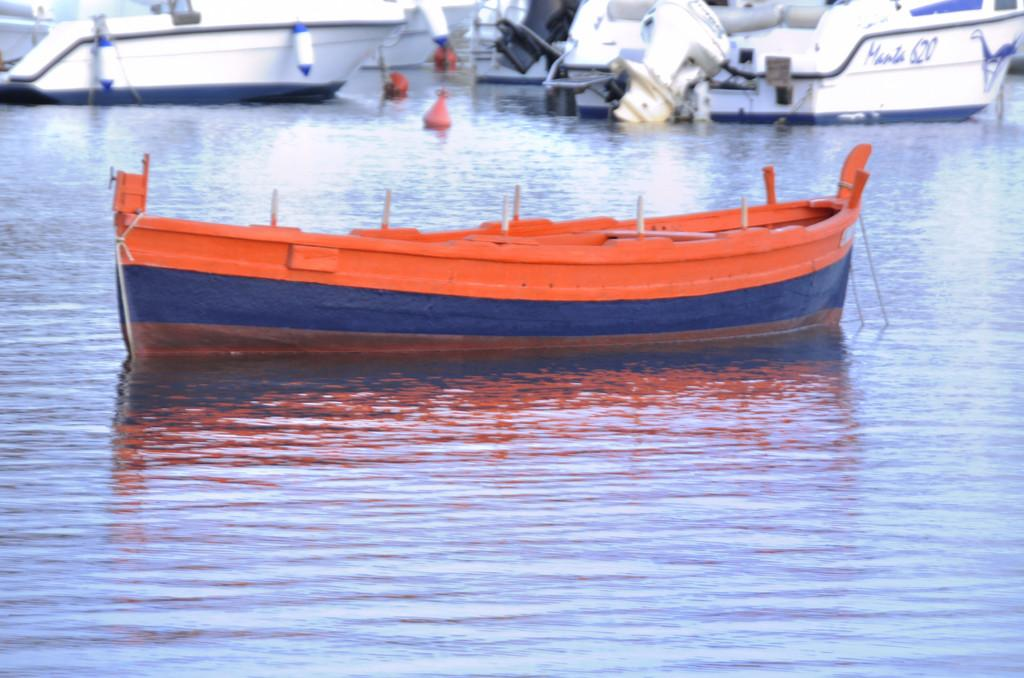<image>
Present a compact description of the photo's key features. Orange boat in front of a white boat that has the number 620. 